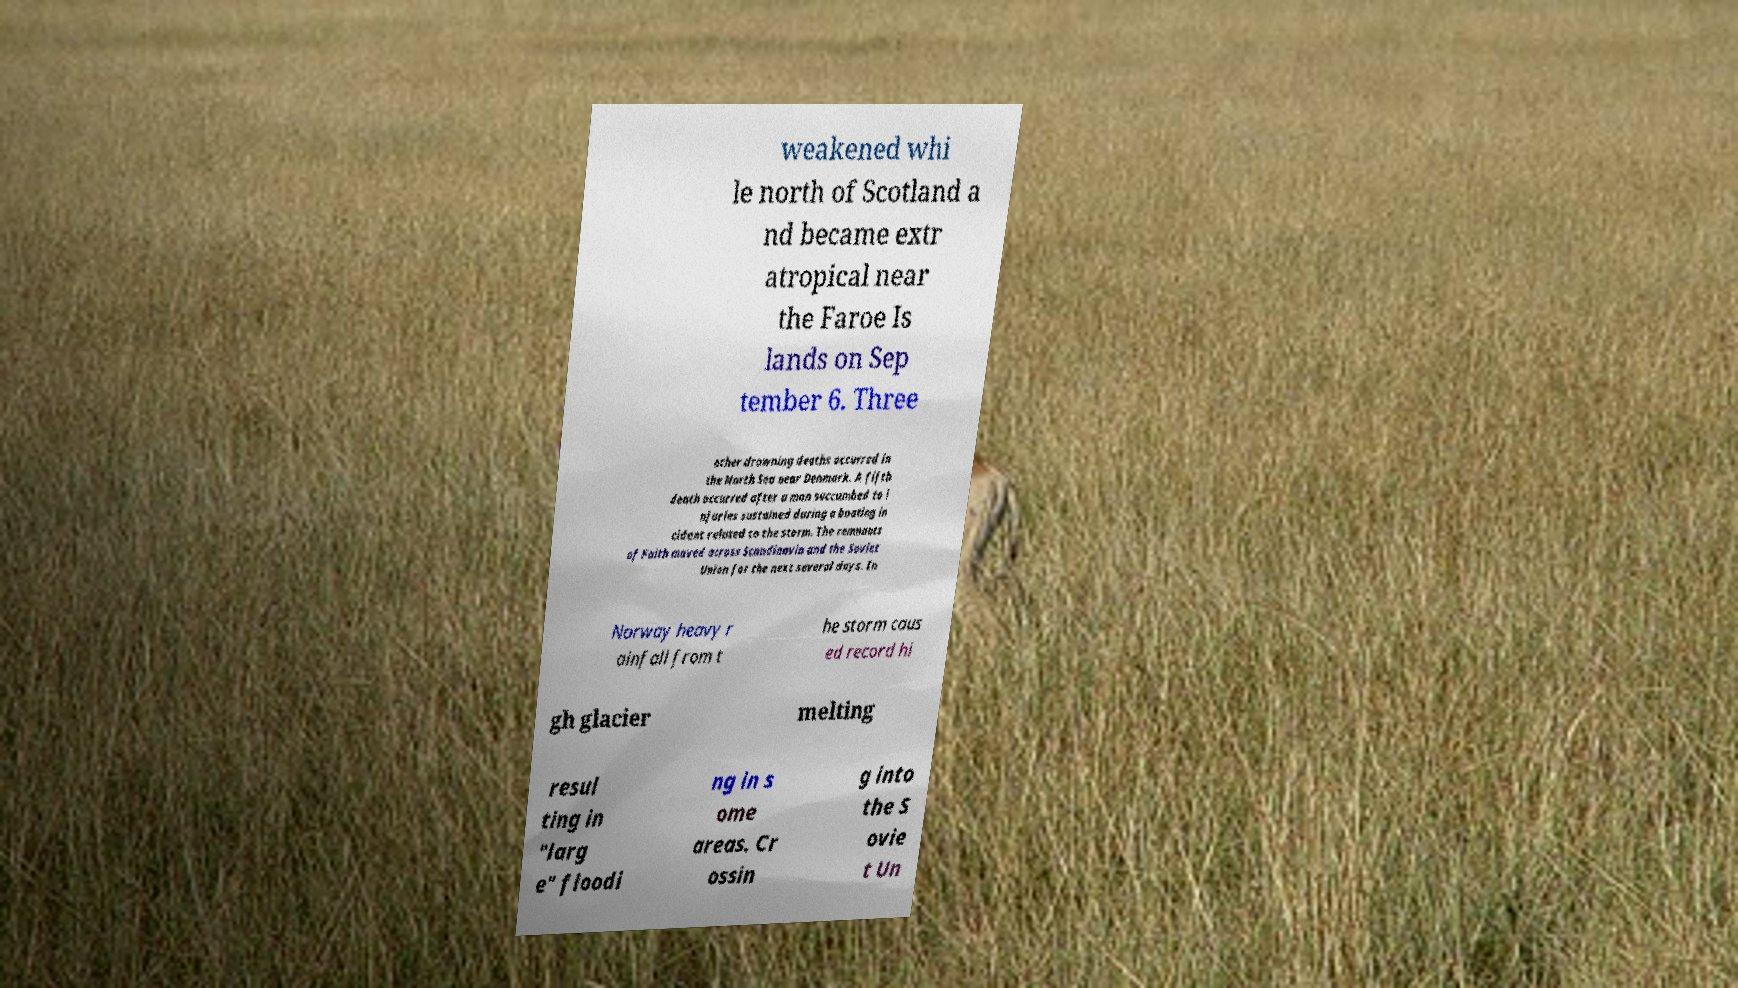I need the written content from this picture converted into text. Can you do that? weakened whi le north of Scotland a nd became extr atropical near the Faroe Is lands on Sep tember 6. Three other drowning deaths occurred in the North Sea near Denmark. A fifth death occurred after a man succumbed to i njuries sustained during a boating in cident related to the storm. The remnants of Faith moved across Scandinavia and the Soviet Union for the next several days. In Norway heavy r ainfall from t he storm caus ed record hi gh glacier melting resul ting in "larg e" floodi ng in s ome areas. Cr ossin g into the S ovie t Un 